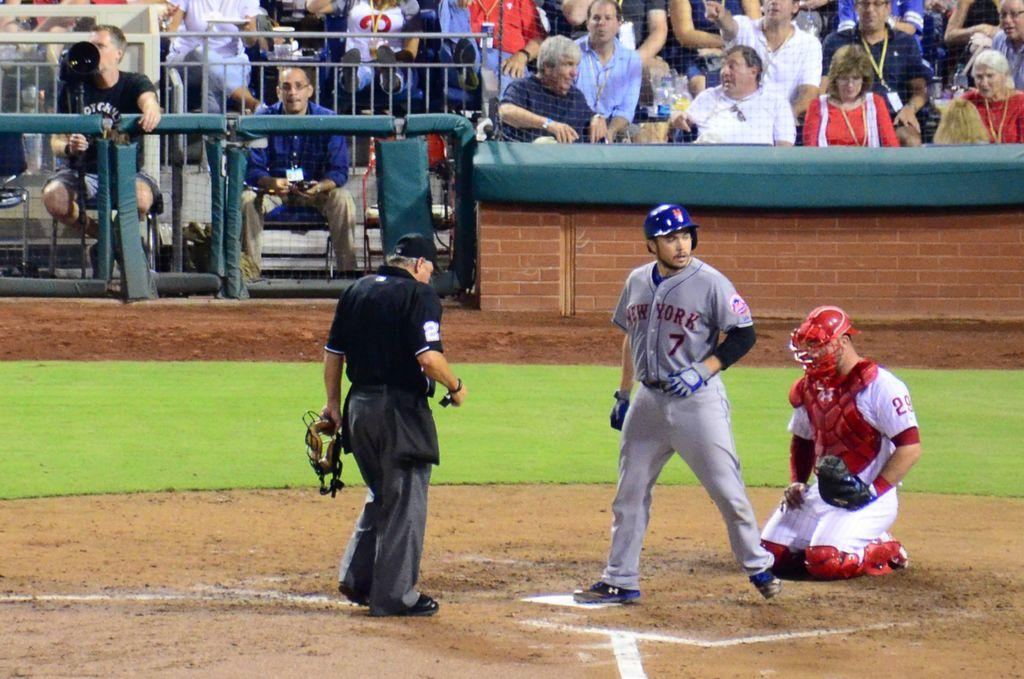<image>
Relay a brief, clear account of the picture shown. a player with a New York shirt on their body 